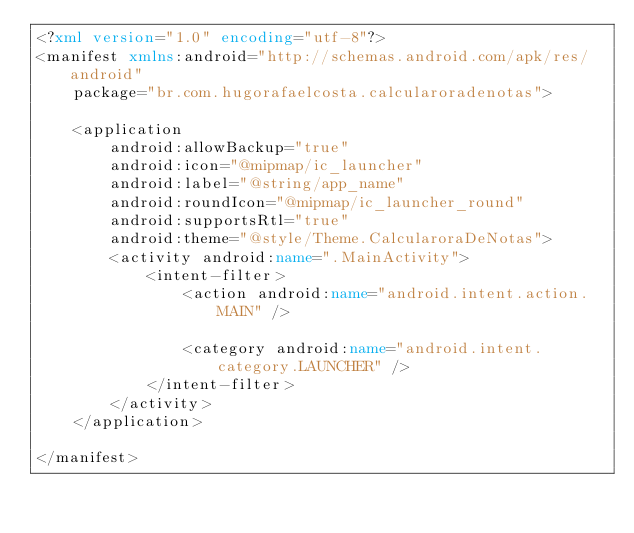Convert code to text. <code><loc_0><loc_0><loc_500><loc_500><_XML_><?xml version="1.0" encoding="utf-8"?>
<manifest xmlns:android="http://schemas.android.com/apk/res/android"
    package="br.com.hugorafaelcosta.calcularoradenotas">

    <application
        android:allowBackup="true"
        android:icon="@mipmap/ic_launcher"
        android:label="@string/app_name"
        android:roundIcon="@mipmap/ic_launcher_round"
        android:supportsRtl="true"
        android:theme="@style/Theme.CalcularoraDeNotas">
        <activity android:name=".MainActivity">
            <intent-filter>
                <action android:name="android.intent.action.MAIN" />

                <category android:name="android.intent.category.LAUNCHER" />
            </intent-filter>
        </activity>
    </application>

</manifest></code> 